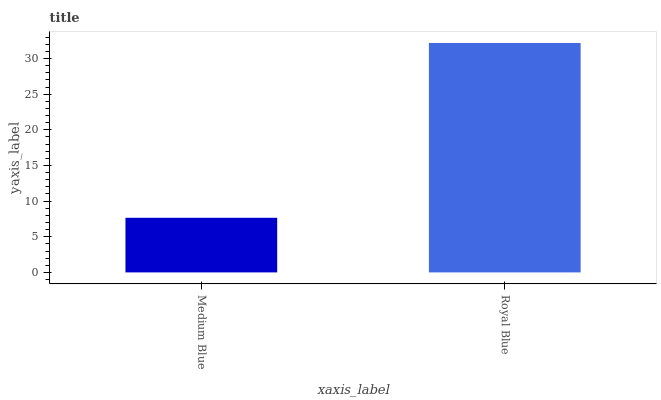Is Medium Blue the minimum?
Answer yes or no. Yes. Is Royal Blue the maximum?
Answer yes or no. Yes. Is Royal Blue the minimum?
Answer yes or no. No. Is Royal Blue greater than Medium Blue?
Answer yes or no. Yes. Is Medium Blue less than Royal Blue?
Answer yes or no. Yes. Is Medium Blue greater than Royal Blue?
Answer yes or no. No. Is Royal Blue less than Medium Blue?
Answer yes or no. No. Is Royal Blue the high median?
Answer yes or no. Yes. Is Medium Blue the low median?
Answer yes or no. Yes. Is Medium Blue the high median?
Answer yes or no. No. Is Royal Blue the low median?
Answer yes or no. No. 